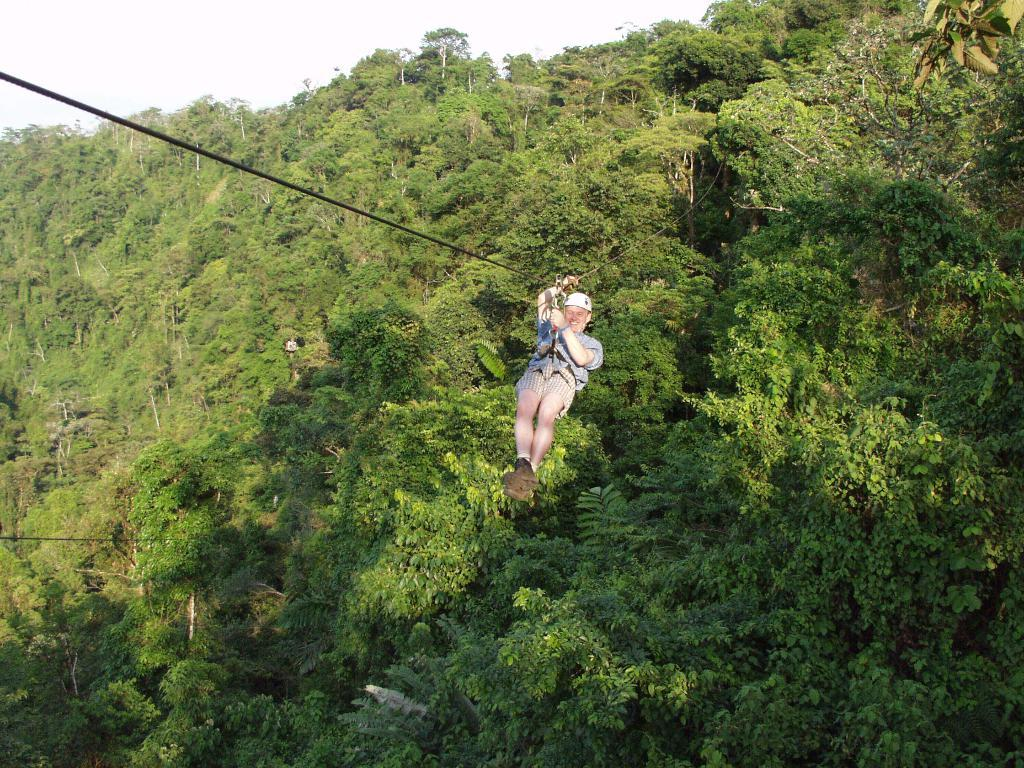What is the main subject in the center of the image? There is a person in the center of the image. What is the person doing in the image? The person is hanging on a rope. What can be seen in the background of the image? There are trees in the background of the image. How would you describe the sky in the image? The sky is cloudy in the image. What type of fork can be seen in the person's hand in the image? There is no fork present in the image; the person is hanging on a rope. What statement is the person making in the image? The image does not depict the person making a statement; it only shows them hanging on a rope. 